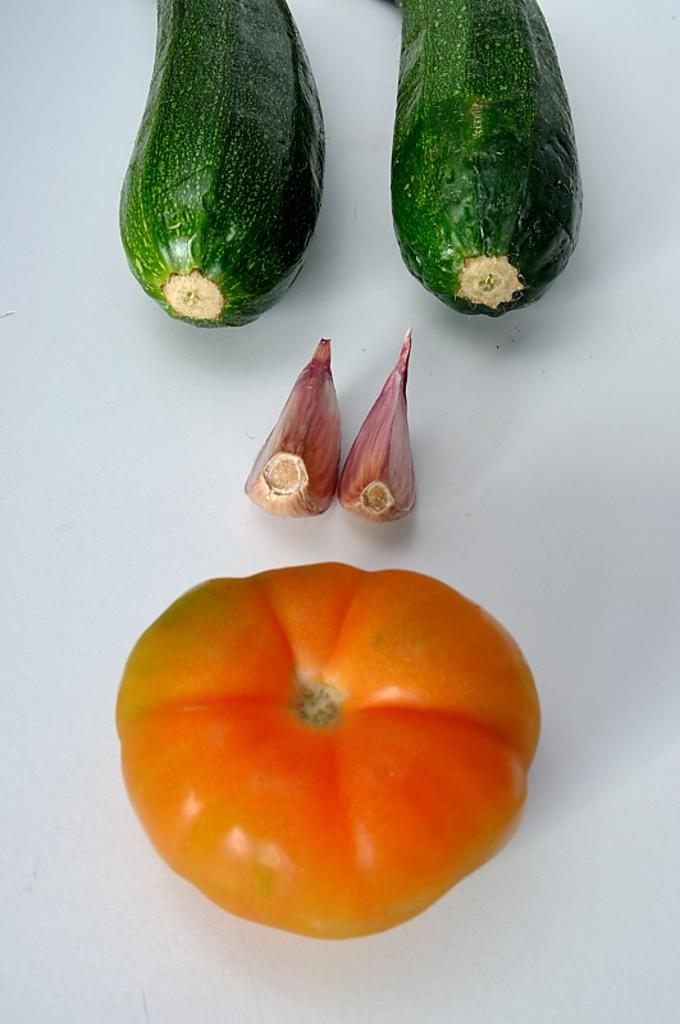What type of food items are present in the image? There are vegetables in the image. What is the color of the surface on which the vegetables are placed? The vegetables are on a white surface. What colors can be seen among the vegetables? The vegetables have colors including red, orange, pink, and green. What is the price of the vegetables in the image? The image does not provide information about the price of the vegetables. 